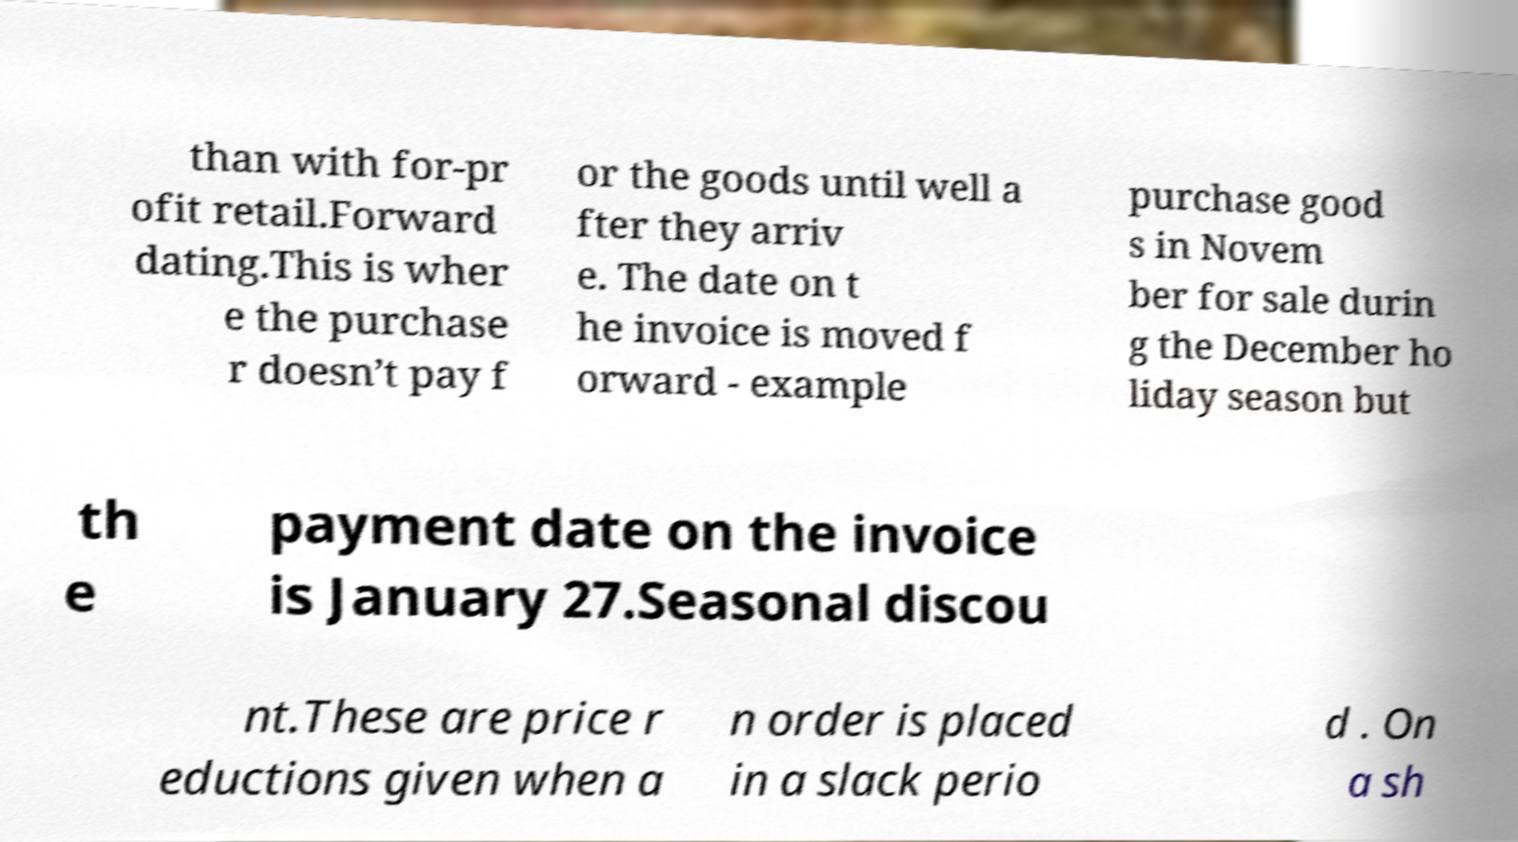Could you assist in decoding the text presented in this image and type it out clearly? than with for-pr ofit retail.Forward dating.This is wher e the purchase r doesn’t pay f or the goods until well a fter they arriv e. The date on t he invoice is moved f orward - example purchase good s in Novem ber for sale durin g the December ho liday season but th e payment date on the invoice is January 27.Seasonal discou nt.These are price r eductions given when a n order is placed in a slack perio d . On a sh 